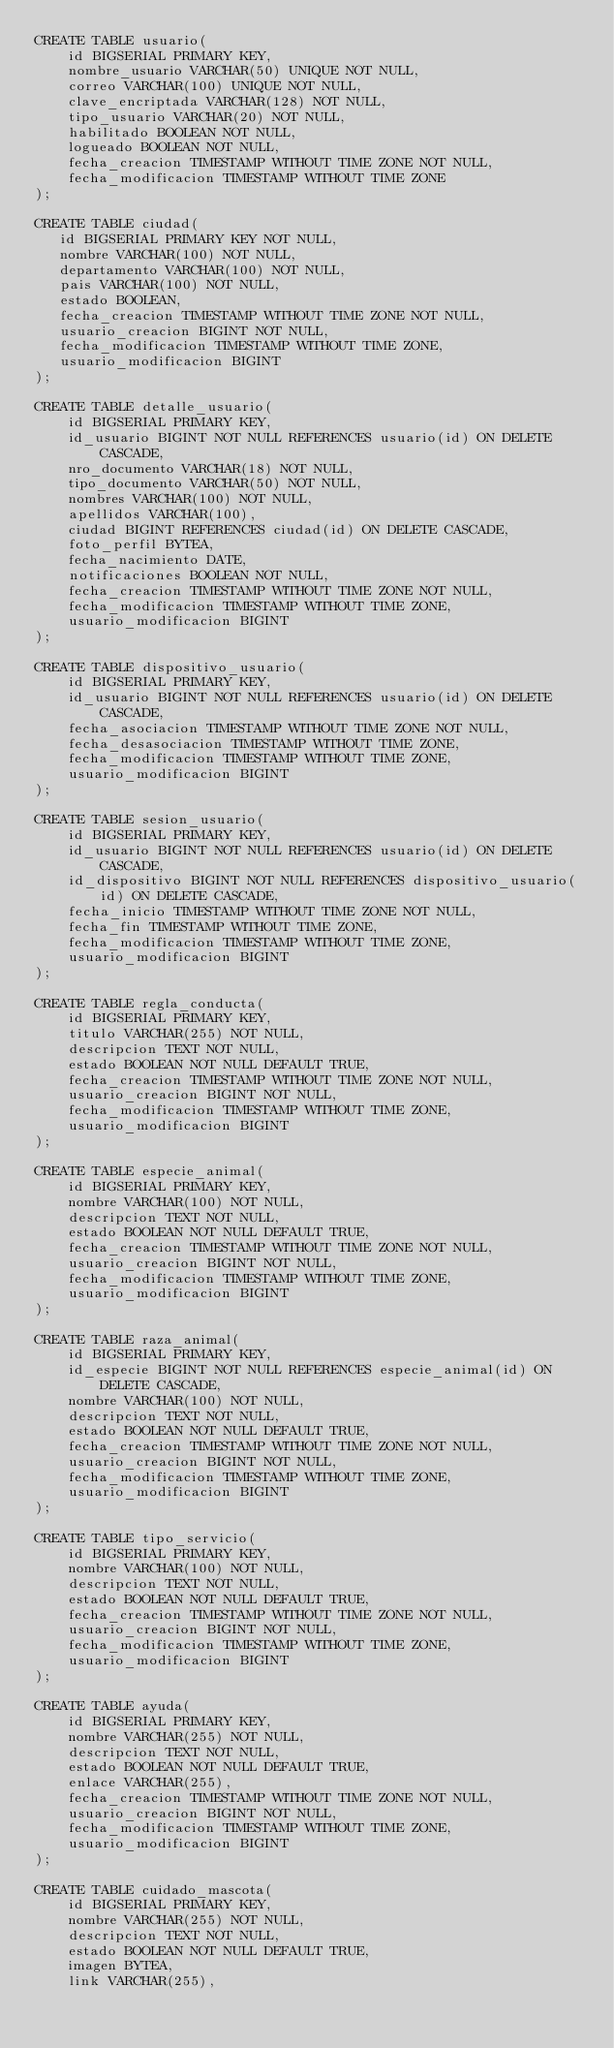<code> <loc_0><loc_0><loc_500><loc_500><_SQL_>CREATE TABLE usuario(
    id BIGSERIAL PRIMARY KEY,
    nombre_usuario VARCHAR(50) UNIQUE NOT NULL,
    correo VARCHAR(100) UNIQUE NOT NULL,
    clave_encriptada VARCHAR(128) NOT NULL,
    tipo_usuario VARCHAR(20) NOT NULL,
    habilitado BOOLEAN NOT NULL,
    logueado BOOLEAN NOT NULL,
    fecha_creacion TIMESTAMP WITHOUT TIME ZONE NOT NULL,
    fecha_modificacion TIMESTAMP WITHOUT TIME ZONE
);

CREATE TABLE ciudad(
   id BIGSERIAL PRIMARY KEY NOT NULL,
   nombre VARCHAR(100) NOT NULL,
   departamento VARCHAR(100) NOT NULL,
   pais VARCHAR(100) NOT NULL,
   estado BOOLEAN,
   fecha_creacion TIMESTAMP WITHOUT TIME ZONE NOT NULL,
   usuario_creacion BIGINT NOT NULL,
   fecha_modificacion TIMESTAMP WITHOUT TIME ZONE,
   usuario_modificacion BIGINT
);

CREATE TABLE detalle_usuario(
    id BIGSERIAL PRIMARY KEY,
    id_usuario BIGINT NOT NULL REFERENCES usuario(id) ON DELETE CASCADE,
    nro_documento VARCHAR(18) NOT NULL,
    tipo_documento VARCHAR(50) NOT NULL,
    nombres VARCHAR(100) NOT NULL,
    apellidos VARCHAR(100),
    ciudad BIGINT REFERENCES ciudad(id) ON DELETE CASCADE,
    foto_perfil BYTEA,
    fecha_nacimiento DATE,
    notificaciones BOOLEAN NOT NULL,
    fecha_creacion TIMESTAMP WITHOUT TIME ZONE NOT NULL,
    fecha_modificacion TIMESTAMP WITHOUT TIME ZONE,
    usuario_modificacion BIGINT
);

CREATE TABLE dispositivo_usuario(
    id BIGSERIAL PRIMARY KEY,
    id_usuario BIGINT NOT NULL REFERENCES usuario(id) ON DELETE CASCADE,
    fecha_asociacion TIMESTAMP WITHOUT TIME ZONE NOT NULL,
    fecha_desasociacion TIMESTAMP WITHOUT TIME ZONE,
    fecha_modificacion TIMESTAMP WITHOUT TIME ZONE,
    usuario_modificacion BIGINT
);

CREATE TABLE sesion_usuario(
    id BIGSERIAL PRIMARY KEY,
    id_usuario BIGINT NOT NULL REFERENCES usuario(id) ON DELETE CASCADE,
    id_dispositivo BIGINT NOT NULL REFERENCES dispositivo_usuario(id) ON DELETE CASCADE,
    fecha_inicio TIMESTAMP WITHOUT TIME ZONE NOT NULL,
    fecha_fin TIMESTAMP WITHOUT TIME ZONE,
    fecha_modificacion TIMESTAMP WITHOUT TIME ZONE,
    usuario_modificacion BIGINT
);

CREATE TABLE regla_conducta(
    id BIGSERIAL PRIMARY KEY,
    titulo VARCHAR(255) NOT NULL,
    descripcion TEXT NOT NULL,
    estado BOOLEAN NOT NULL DEFAULT TRUE,
    fecha_creacion TIMESTAMP WITHOUT TIME ZONE NOT NULL,
    usuario_creacion BIGINT NOT NULL,
    fecha_modificacion TIMESTAMP WITHOUT TIME ZONE,
    usuario_modificacion BIGINT
);

CREATE TABLE especie_animal(
    id BIGSERIAL PRIMARY KEY,
    nombre VARCHAR(100) NOT NULL,
    descripcion TEXT NOT NULL,
    estado BOOLEAN NOT NULL DEFAULT TRUE,
    fecha_creacion TIMESTAMP WITHOUT TIME ZONE NOT NULL,
    usuario_creacion BIGINT NOT NULL,
    fecha_modificacion TIMESTAMP WITHOUT TIME ZONE,
    usuario_modificacion BIGINT
);

CREATE TABLE raza_animal(
    id BIGSERIAL PRIMARY KEY,
    id_especie BIGINT NOT NULL REFERENCES especie_animal(id) ON DELETE CASCADE,
    nombre VARCHAR(100) NOT NULL,
    descripcion TEXT NOT NULL,
    estado BOOLEAN NOT NULL DEFAULT TRUE,
    fecha_creacion TIMESTAMP WITHOUT TIME ZONE NOT NULL,
    usuario_creacion BIGINT NOT NULL,
    fecha_modificacion TIMESTAMP WITHOUT TIME ZONE,
    usuario_modificacion BIGINT
);

CREATE TABLE tipo_servicio(
    id BIGSERIAL PRIMARY KEY,
    nombre VARCHAR(100) NOT NULL,
    descripcion TEXT NOT NULL,
    estado BOOLEAN NOT NULL DEFAULT TRUE,
    fecha_creacion TIMESTAMP WITHOUT TIME ZONE NOT NULL,
    usuario_creacion BIGINT NOT NULL,
    fecha_modificacion TIMESTAMP WITHOUT TIME ZONE,
    usuario_modificacion BIGINT
);

CREATE TABLE ayuda(
    id BIGSERIAL PRIMARY KEY,
    nombre VARCHAR(255) NOT NULL,
    descripcion TEXT NOT NULL,
    estado BOOLEAN NOT NULL DEFAULT TRUE,
    enlace VARCHAR(255),
    fecha_creacion TIMESTAMP WITHOUT TIME ZONE NOT NULL,
    usuario_creacion BIGINT NOT NULL,
    fecha_modificacion TIMESTAMP WITHOUT TIME ZONE,
    usuario_modificacion BIGINT
);

CREATE TABLE cuidado_mascota(
    id BIGSERIAL PRIMARY KEY,
    nombre VARCHAR(255) NOT NULL,
    descripcion TEXT NOT NULL,
    estado BOOLEAN NOT NULL DEFAULT TRUE,
    imagen BYTEA,
    link VARCHAR(255),</code> 